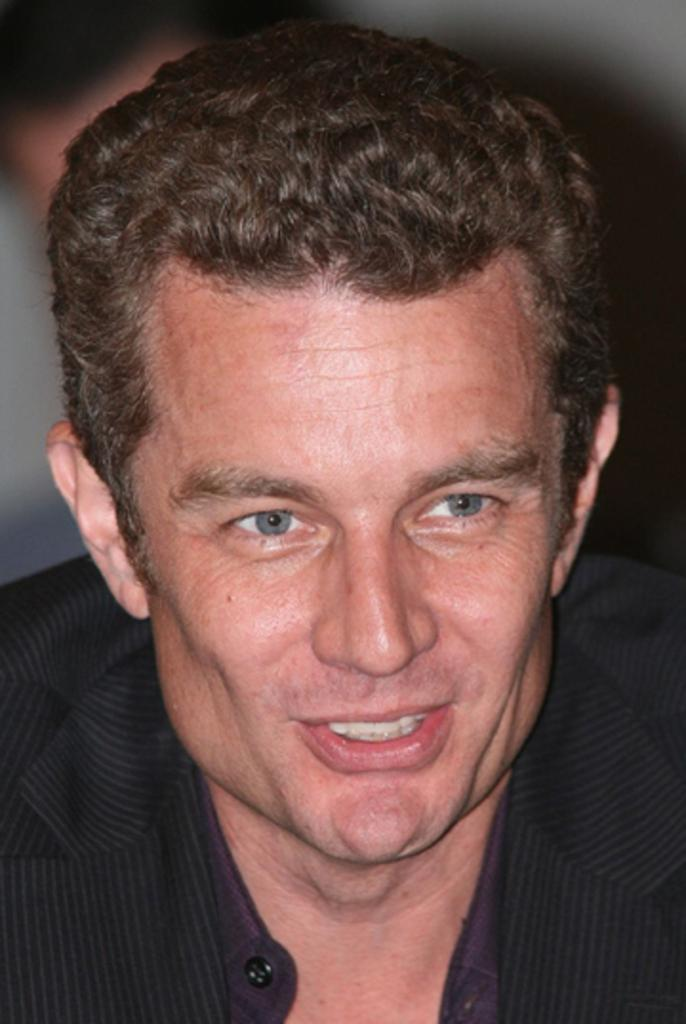What is the main subject of the image? There is a man's face in the image. Can you describe the background of the image? The background of the image is blurry. What color is the balloon that the man is holding in the image? There is no balloon present in the image. What is the reason behind the man's facial expression in the image? We cannot determine the reason behind the man's facial expression from the image alone. 